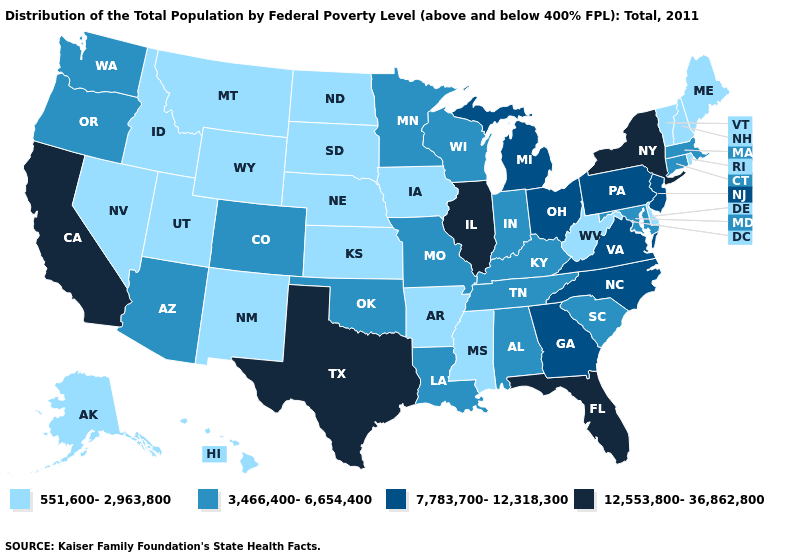Which states have the lowest value in the USA?
Write a very short answer. Alaska, Arkansas, Delaware, Hawaii, Idaho, Iowa, Kansas, Maine, Mississippi, Montana, Nebraska, Nevada, New Hampshire, New Mexico, North Dakota, Rhode Island, South Dakota, Utah, Vermont, West Virginia, Wyoming. Name the states that have a value in the range 12,553,800-36,862,800?
Give a very brief answer. California, Florida, Illinois, New York, Texas. Which states have the lowest value in the USA?
Answer briefly. Alaska, Arkansas, Delaware, Hawaii, Idaho, Iowa, Kansas, Maine, Mississippi, Montana, Nebraska, Nevada, New Hampshire, New Mexico, North Dakota, Rhode Island, South Dakota, Utah, Vermont, West Virginia, Wyoming. What is the value of Mississippi?
Give a very brief answer. 551,600-2,963,800. Does the map have missing data?
Keep it brief. No. Does the first symbol in the legend represent the smallest category?
Keep it brief. Yes. Does the first symbol in the legend represent the smallest category?
Write a very short answer. Yes. Does Georgia have a lower value than New York?
Answer briefly. Yes. What is the highest value in the USA?
Concise answer only. 12,553,800-36,862,800. Which states have the lowest value in the MidWest?
Short answer required. Iowa, Kansas, Nebraska, North Dakota, South Dakota. What is the value of Idaho?
Concise answer only. 551,600-2,963,800. Does Hawaii have the same value as Arkansas?
Be succinct. Yes. Name the states that have a value in the range 551,600-2,963,800?
Concise answer only. Alaska, Arkansas, Delaware, Hawaii, Idaho, Iowa, Kansas, Maine, Mississippi, Montana, Nebraska, Nevada, New Hampshire, New Mexico, North Dakota, Rhode Island, South Dakota, Utah, Vermont, West Virginia, Wyoming. Does the first symbol in the legend represent the smallest category?
Quick response, please. Yes. Among the states that border Maryland , does Virginia have the lowest value?
Write a very short answer. No. 